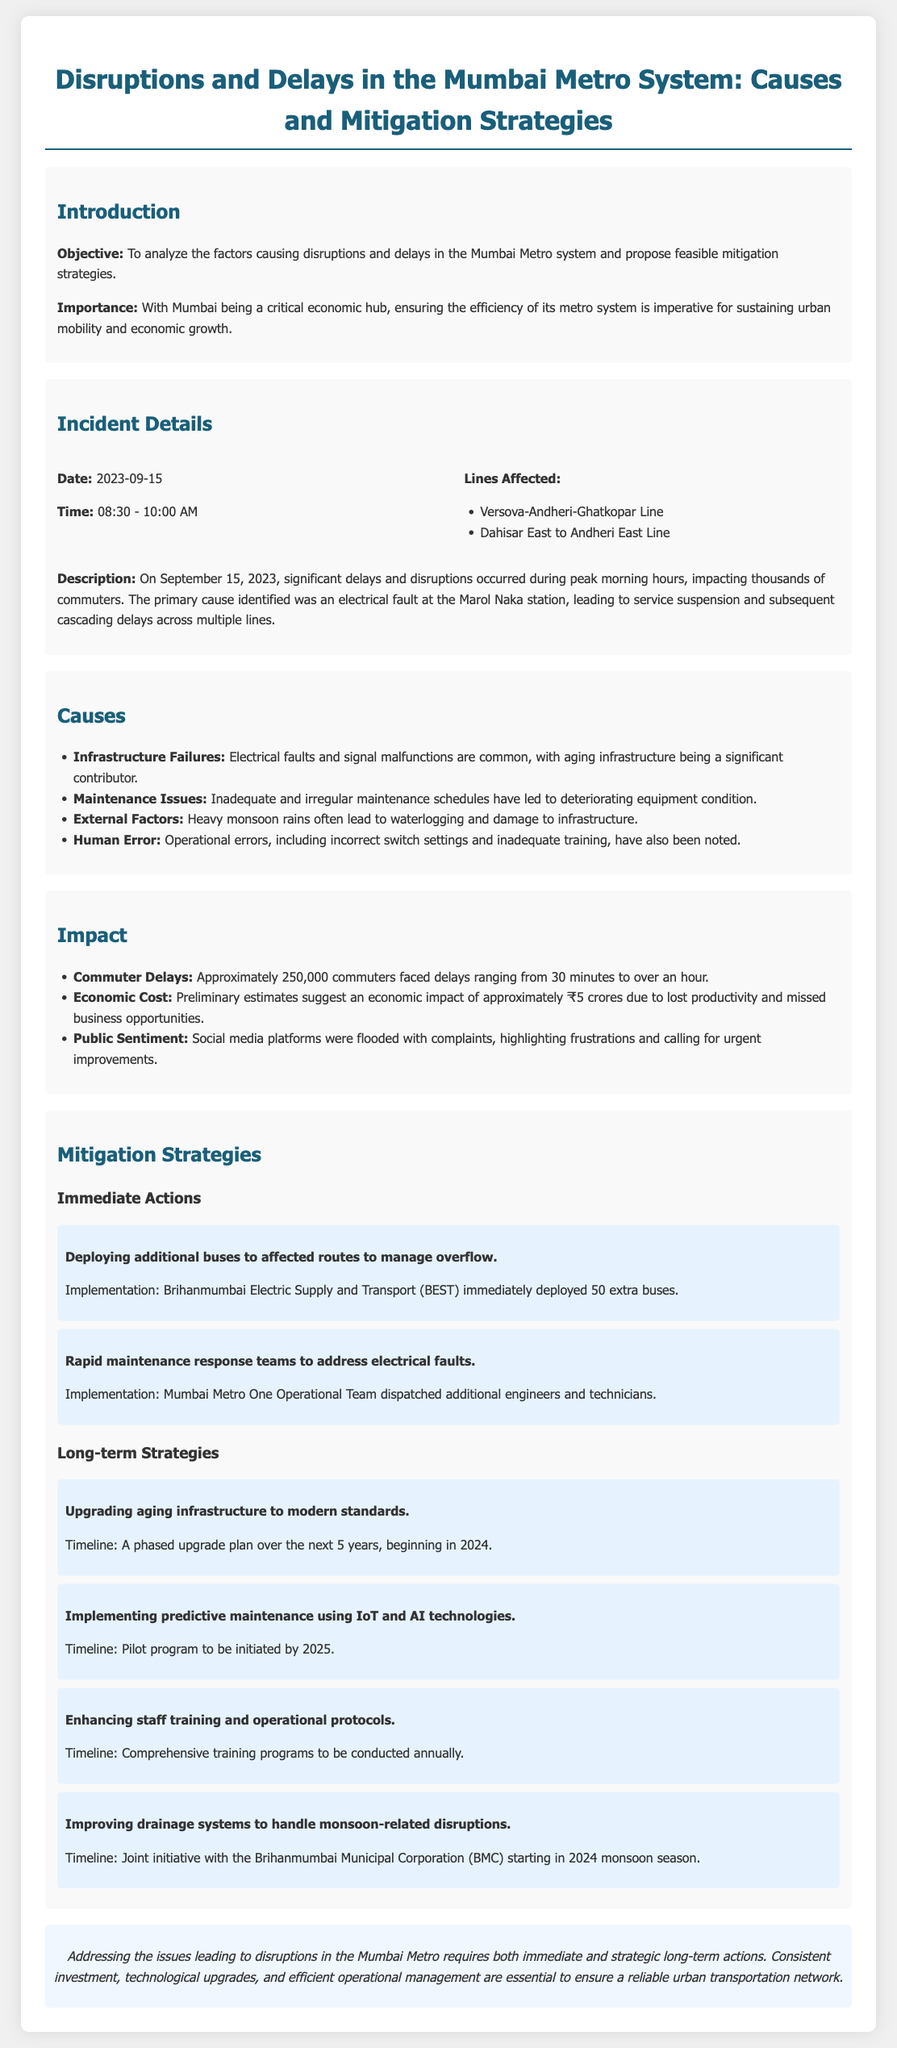What was the date of the incident? The incident occurred on September 15, 2023, as stated in the document.
Answer: September 15, 2023 What time did the disruptions occur? The disruptions were recorded from 08:30 to 10:00 AM as noted in the incident details section.
Answer: 08:30 - 10:00 AM How many additional buses were deployed to manage overflow? The document mentions that 50 extra buses were deployed for this purpose.
Answer: 50 What was the estimated economic impact of the disruptions? The preliminary estimates indicate an economic impact of approximately ₹5 crores due to the disruptions.
Answer: ₹5 crores What are the primary causes of disruptions mentioned? The document lists four primary causes: infrastructure failures, maintenance issues, external factors, and human error.
Answer: Infrastructure failures, maintenance issues, external factors, human error What is one long-term strategy proposed for the Mumbai Metro system? One long-term strategy mentioned in the report is upgrading aging infrastructure to modern standards.
Answer: Upgrading aging infrastructure What timeline is set for the pilot program of predictive maintenance? The pilot program for predictive maintenance is planned to be initiated by 2025 as indicated in the document.
Answer: 2025 Which lines were affected by the disruptions? The affected lines include the Versova-Andheri-Ghatkopar Line and the Dahisar East to Andheri East Line, as listed in the incident details.
Answer: Versova-Andheri-Ghatkopar Line, Dahisar East to Andheri East Line What immediate action was taken for electrical faults? The report states that rapid maintenance response teams were dispatched to address electrical faults.
Answer: Dispatching rapid maintenance response teams 